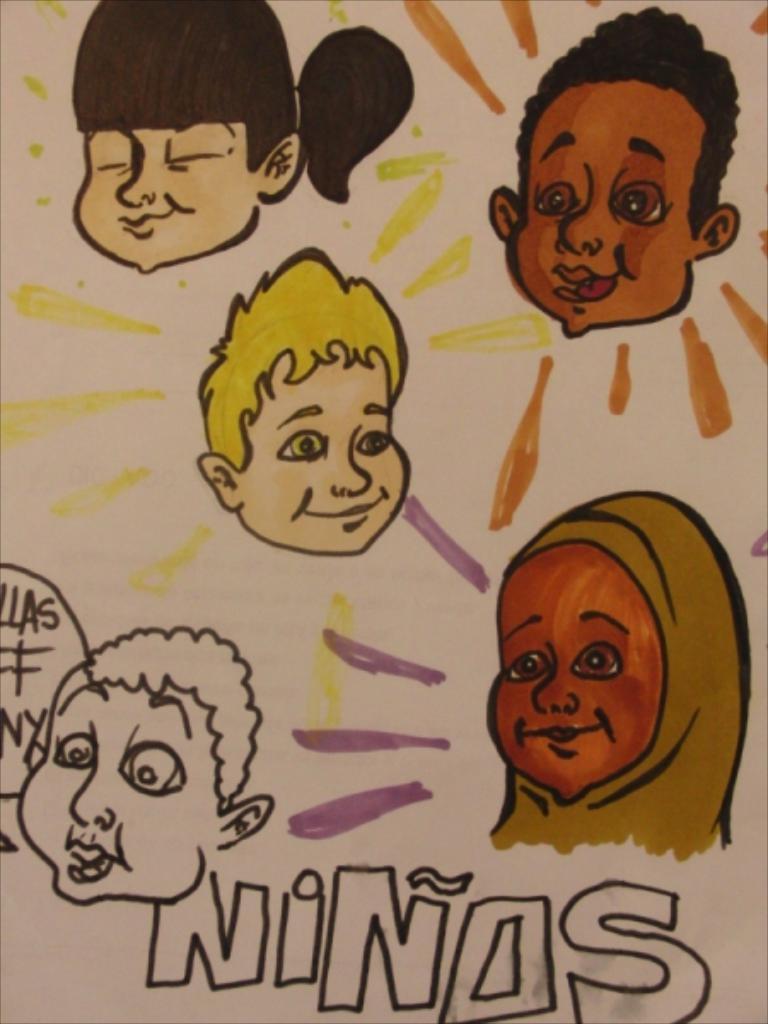How would you summarize this image in a sentence or two? In the image there is a poster with cartoon faces. And also there is some text and some designs on it. 